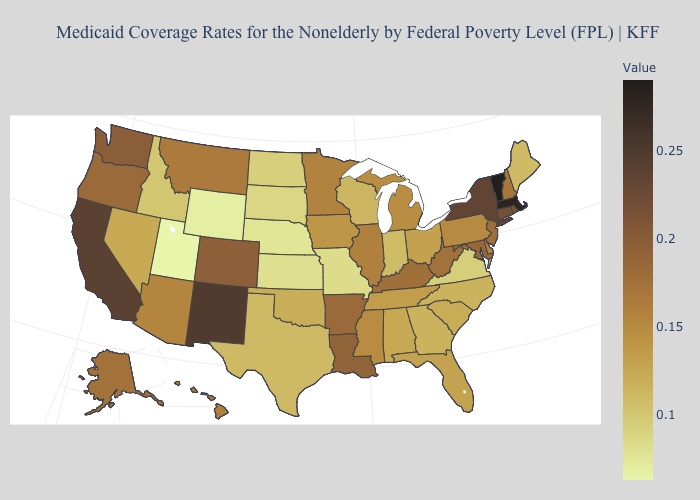Among the states that border Arizona , which have the lowest value?
Write a very short answer. Utah. Which states hav the highest value in the Northeast?
Quick response, please. Vermont. Does Massachusetts have the lowest value in the Northeast?
Be succinct. No. Among the states that border California , does Nevada have the lowest value?
Quick response, please. Yes. Among the states that border Mississippi , which have the highest value?
Quick response, please. Louisiana. Among the states that border Minnesota , does Iowa have the highest value?
Keep it brief. Yes. 